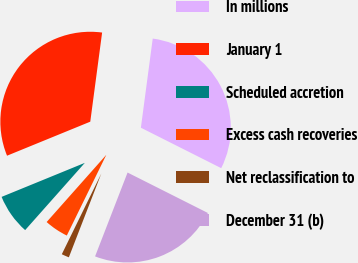<chart> <loc_0><loc_0><loc_500><loc_500><pie_chart><fcel>In millions<fcel>January 1<fcel>Scheduled accretion<fcel>Excess cash recoveries<fcel>Net reclassification to<fcel>December 31 (b)<nl><fcel>30.32%<fcel>33.28%<fcel>7.27%<fcel>4.31%<fcel>1.36%<fcel>23.46%<nl></chart> 